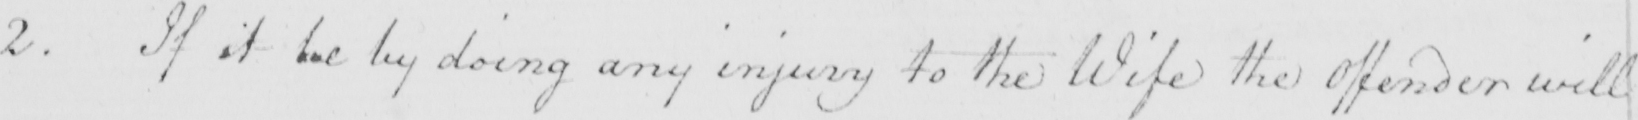Please provide the text content of this handwritten line. 2 . If it be by doing any injury to the Wife the Offender will 